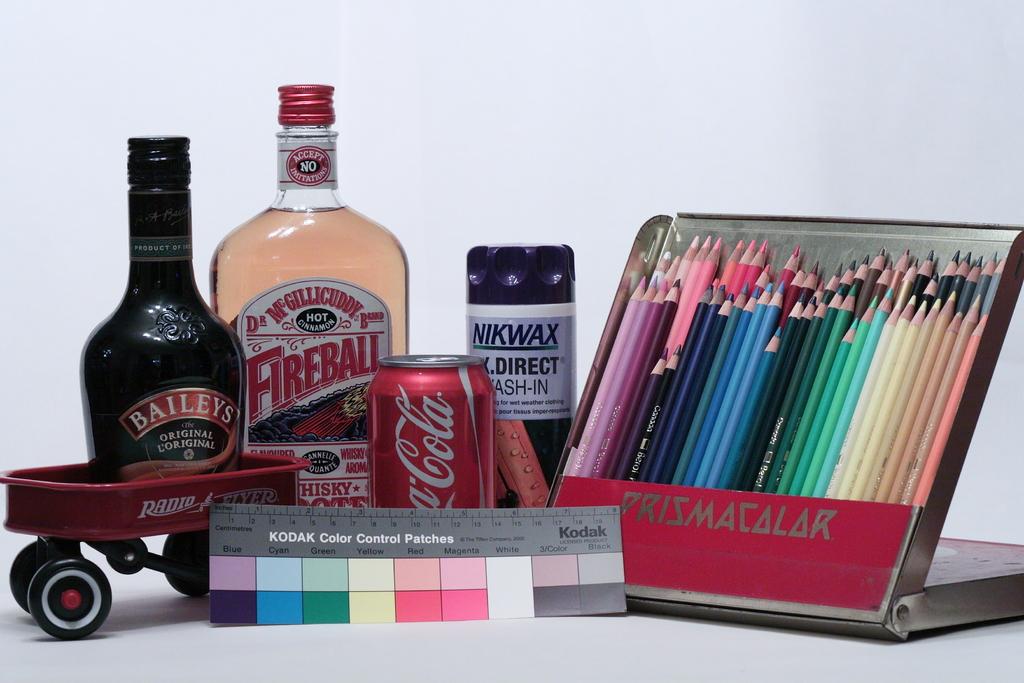What's the name of the colouring pencils?
Provide a succinct answer. Prismacolor. What is the name of the clear bottle?
Offer a terse response. Fireball. 